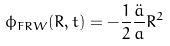<formula> <loc_0><loc_0><loc_500><loc_500>\phi _ { F R W } ( R , t ) = - \frac { 1 } { 2 } \frac { \ddot { a } } { a } R ^ { 2 }</formula> 